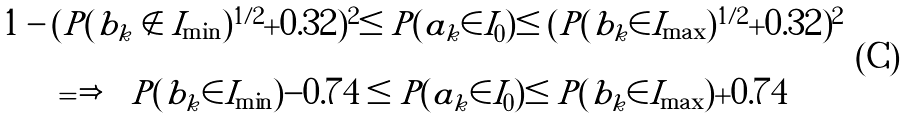<formula> <loc_0><loc_0><loc_500><loc_500>\begin{array} { c } 1 - ( P ( b _ { k } \notin I _ { \min } ) ^ { 1 / 2 } + 0 . 3 2 ) ^ { 2 } \leq P ( a _ { k } \in I _ { 0 } ) \leq ( P ( b _ { k } \in I _ { \max } ) ^ { 1 / 2 } + 0 . 3 2 ) ^ { 2 } \\ \\ \Longrightarrow \quad P ( b _ { k } \in I _ { \min } ) - 0 . 7 4 \leq P ( a _ { k } \in I _ { 0 } ) \leq P ( b _ { k } \in I _ { \max } ) + 0 . 7 4 \end{array}</formula> 